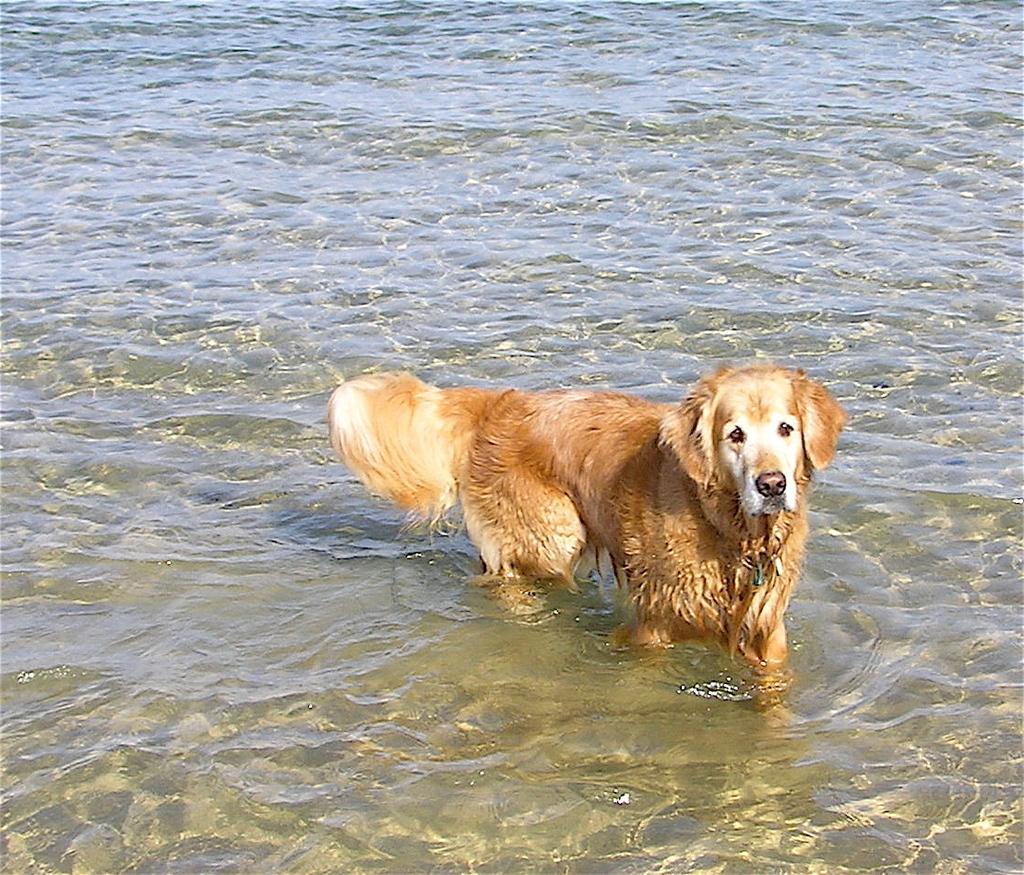How would you summarize this image in a sentence or two? In this image we can see a dog standing in the water. 